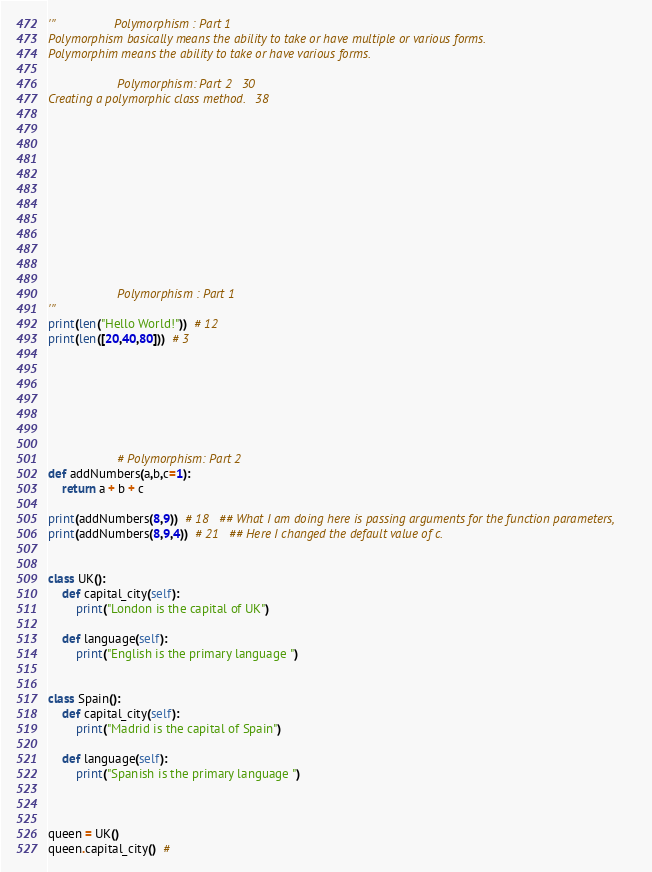<code> <loc_0><loc_0><loc_500><loc_500><_Python_>'''                 Polymorphism : Part 1
Polymorphism basically means the ability to take or have multiple or various forms.
Polymorphim means the ability to take or have various forms.

                    Polymorphism: Part 2   30
Creating a polymorphic class method.   38












                    Polymorphism : Part 1
'''
print(len("Hello World!"))  # 12
print(len([20,40,80]))  # 3







                    # Polymorphism: Part 2
def addNumbers(a,b,c=1):
    return a + b + c

print(addNumbers(8,9))  # 18   ## What I am doing here is passing arguments for the function parameters,
print(addNumbers(8,9,4))  # 21   ## Here I changed the default value of c.


class UK():
    def capital_city(self):
        print("London is the capital of UK")

    def language(self):
        print("English is the primary language ")


class Spain():
    def capital_city(self):
        print("Madrid is the capital of Spain")

    def language(self):
        print("Spanish is the primary language ")



queen = UK()
queen.capital_city()  #
</code> 